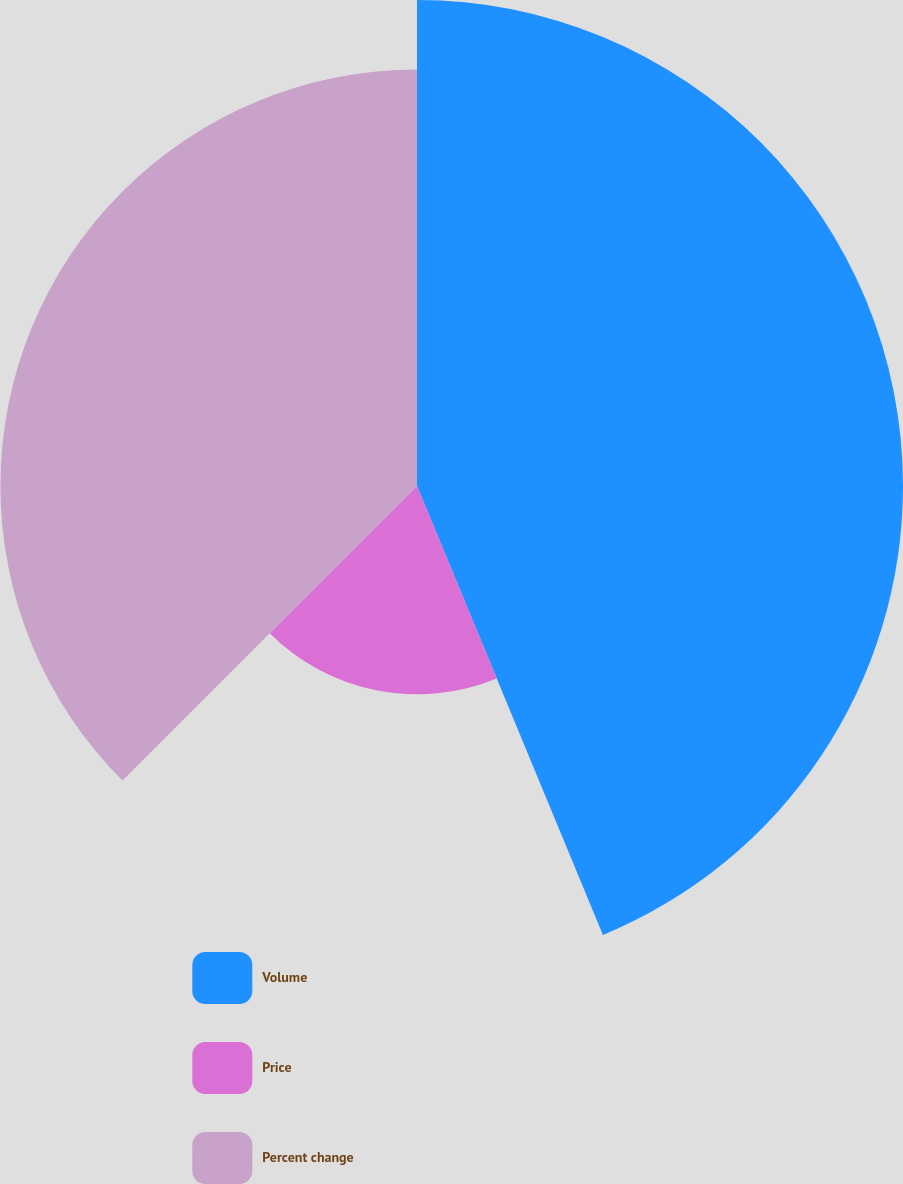Convert chart to OTSL. <chart><loc_0><loc_0><loc_500><loc_500><pie_chart><fcel>Volume<fcel>Price<fcel>Percent change<nl><fcel>43.75%<fcel>18.75%<fcel>37.5%<nl></chart> 